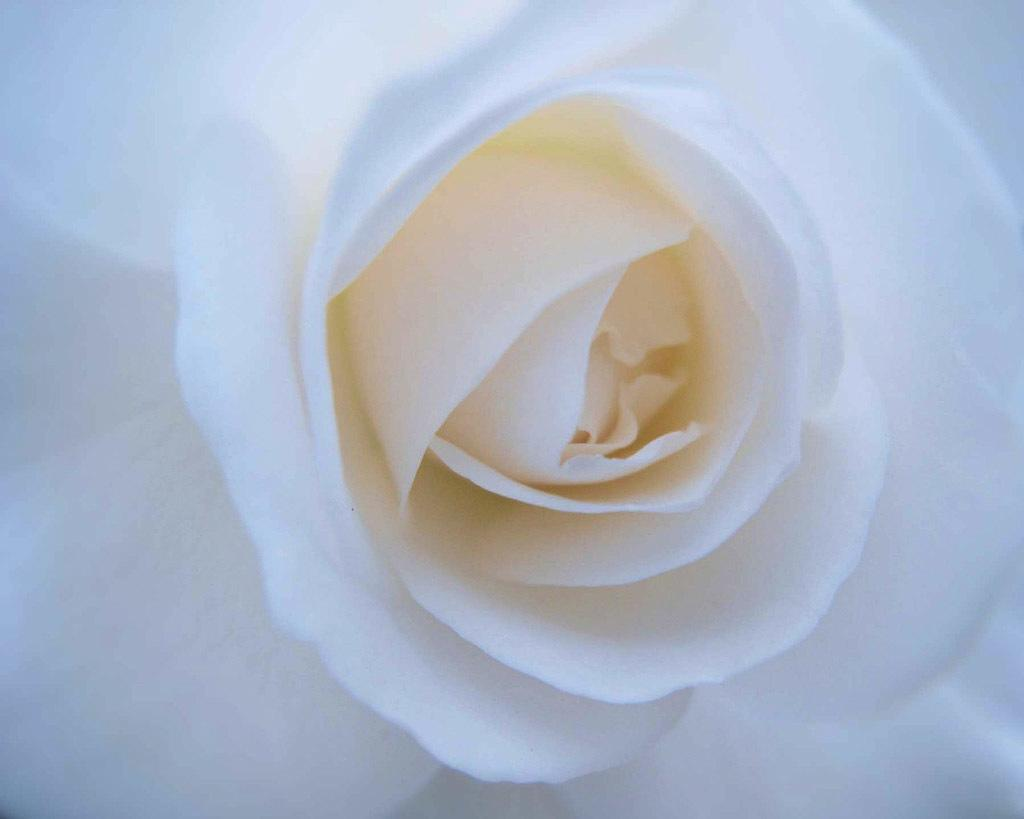What type of flower is present in the image? There is a white flower in the image. What type of beam can be seen supporting the seashore in the image? There is no beam or seashore present in the image; it only features a white flower. 